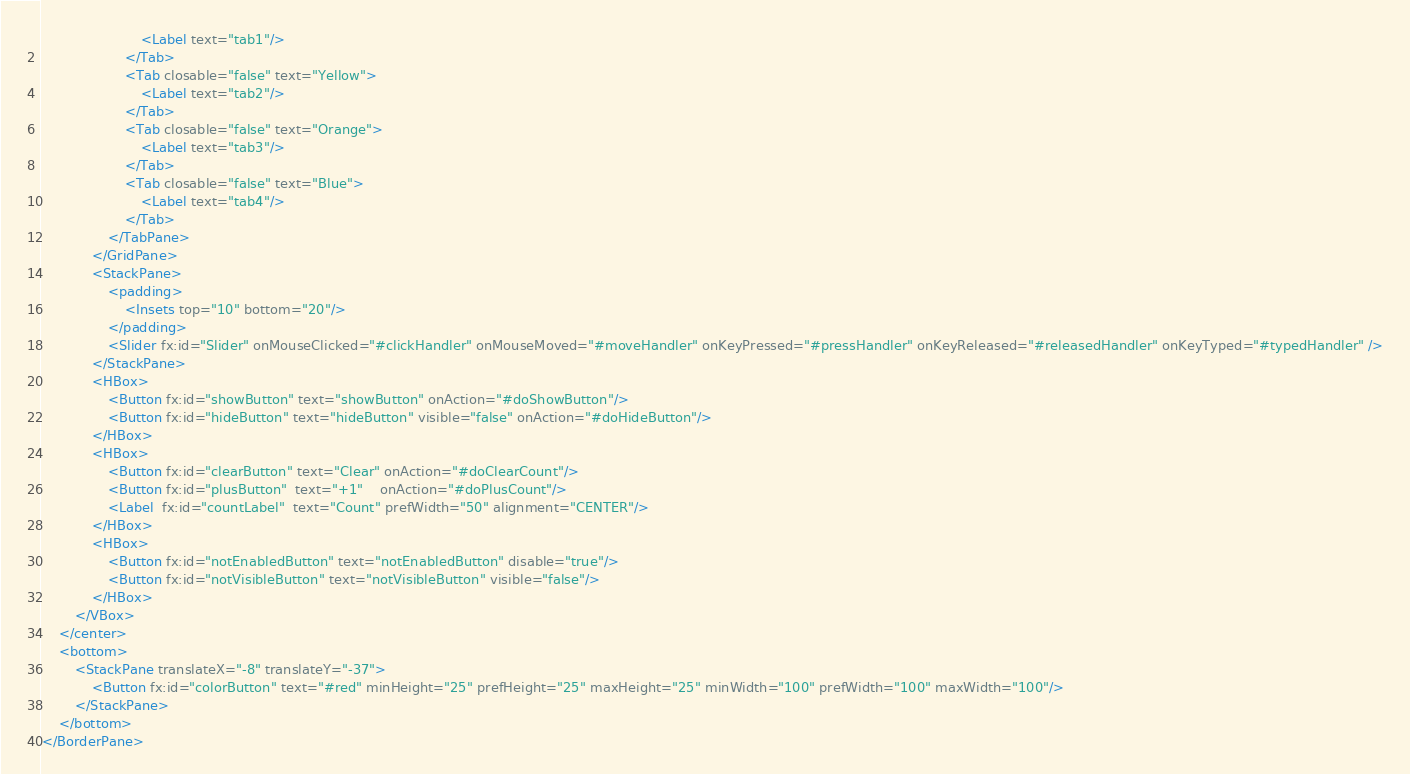<code> <loc_0><loc_0><loc_500><loc_500><_XML_>                        <Label text="tab1"/>
                    </Tab>
                    <Tab closable="false" text="Yellow">
                        <Label text="tab2"/>
                    </Tab>
                    <Tab closable="false" text="Orange">
                        <Label text="tab3"/>
                    </Tab>
                    <Tab closable="false" text="Blue">
                        <Label text="tab4"/>
                    </Tab>
                </TabPane>
            </GridPane>
            <StackPane>
                <padding>
                    <Insets top="10" bottom="20"/>
                </padding>
                <Slider fx:id="Slider" onMouseClicked="#clickHandler" onMouseMoved="#moveHandler" onKeyPressed="#pressHandler" onKeyReleased="#releasedHandler" onKeyTyped="#typedHandler" />
            </StackPane>
            <HBox>
                <Button fx:id="showButton" text="showButton" onAction="#doShowButton"/>
                <Button fx:id="hideButton" text="hideButton" visible="false" onAction="#doHideButton"/>
            </HBox>
            <HBox>
                <Button fx:id="clearButton" text="Clear" onAction="#doClearCount"/>
                <Button fx:id="plusButton"  text="+1"    onAction="#doPlusCount"/>
                <Label  fx:id="countLabel"  text="Count" prefWidth="50" alignment="CENTER"/>
            </HBox>
            <HBox>
                <Button fx:id="notEnabledButton" text="notEnabledButton" disable="true"/>
                <Button fx:id="notVisibleButton" text="notVisibleButton" visible="false"/>
            </HBox>
        </VBox>
    </center>
    <bottom>
        <StackPane translateX="-8" translateY="-37">
            <Button fx:id="colorButton" text="#red" minHeight="25" prefHeight="25" maxHeight="25" minWidth="100" prefWidth="100" maxWidth="100"/>
        </StackPane>
    </bottom>
</BorderPane>
</code> 